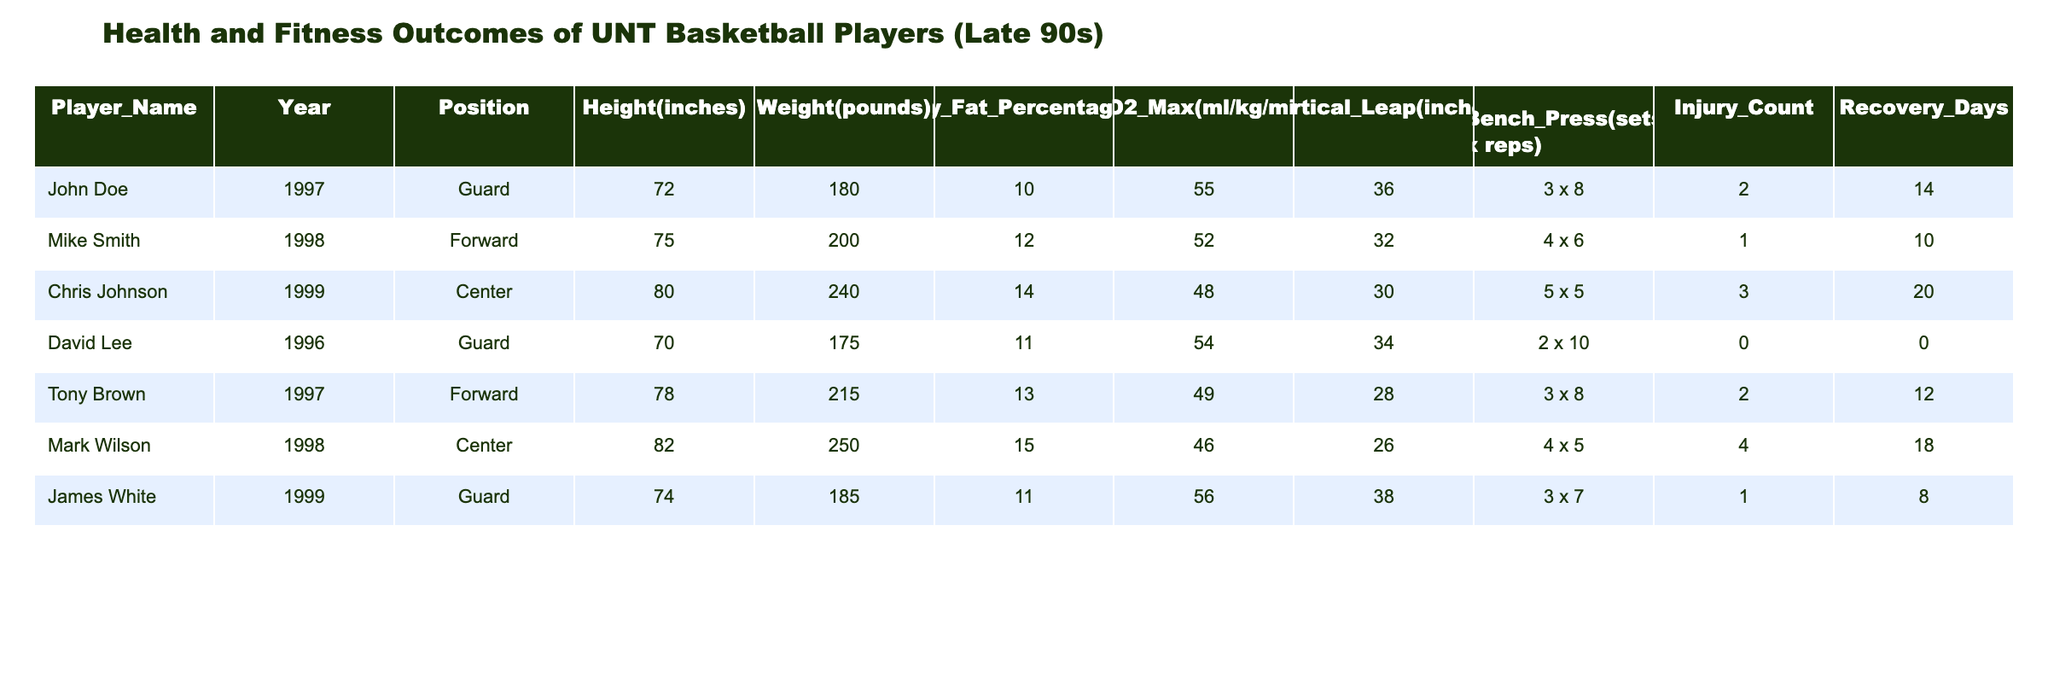What is the body fat percentage of Chris Johnson? The table directly lists the body fat percentage for each player. For Chris Johnson, the body fat percentage is clearly stated as 14%.
Answer: 14% How many sets and reps did Mike Smith perform in bench press? The table shows that Mike Smith's bench press performance is listed as "4 x 6," which indicates he did 4 sets of 6 reps.
Answer: 4 x 6 What is the average VO2 Max among the players listed? To find the average VO2 Max, we sum up all the VO2 Max values (55 + 52 + 48 + 54 + 49 + 46 + 56) = 360 and divide by the number of players (7), giving us 360 / 7 = 51.43 (rounded to two decimal places).
Answer: 51.43 Did David Lee have any injury counts? The table shows David Lee's injury count as 0, indicating he did not have any injuries during the recorded time.
Answer: Yes Which player had the highest vertical leap and what was the value? By reviewing the vertical leap values in the table, we can see that James White had the highest vertical leap value of 38 inches.
Answer: James White, 38 inches What is the total weight of all players combined? To calculate the total weight of all players, we sum their weights: (180 + 200 + 240 + 175 + 215 + 250 + 185) = 1450 pounds.
Answer: 1450 pounds How many players recorded more than 10% body fat? By examining the body fat percentages in the table, we find that Mike Smith (12%), Chris Johnson (14%), Tony Brown (13%), and Mark Wilson (15%) have more than 10% body fat, totaling 4 players.
Answer: 4 players What is the average recovery days for all players? The recovery days are listed as 14, 10, 20, 0, 12, 18, and 8. We sum them up: (14 + 10 + 20 + 0 + 12 + 18 + 8) = 82 and divide by the number of players (7), giving us an average of 82 / 7 = 11.71 (rounded to two decimal places).
Answer: 11.71 Did any player perform better than 3 sets in bench press? Four players had bench press performance greater than 3 sets: Chris Johnson (5 sets), Mike Smith (4 sets), Mark Wilson (4 sets), and James White (3 sets). Therefore, yes, some players performed better than 3 sets.
Answer: Yes 